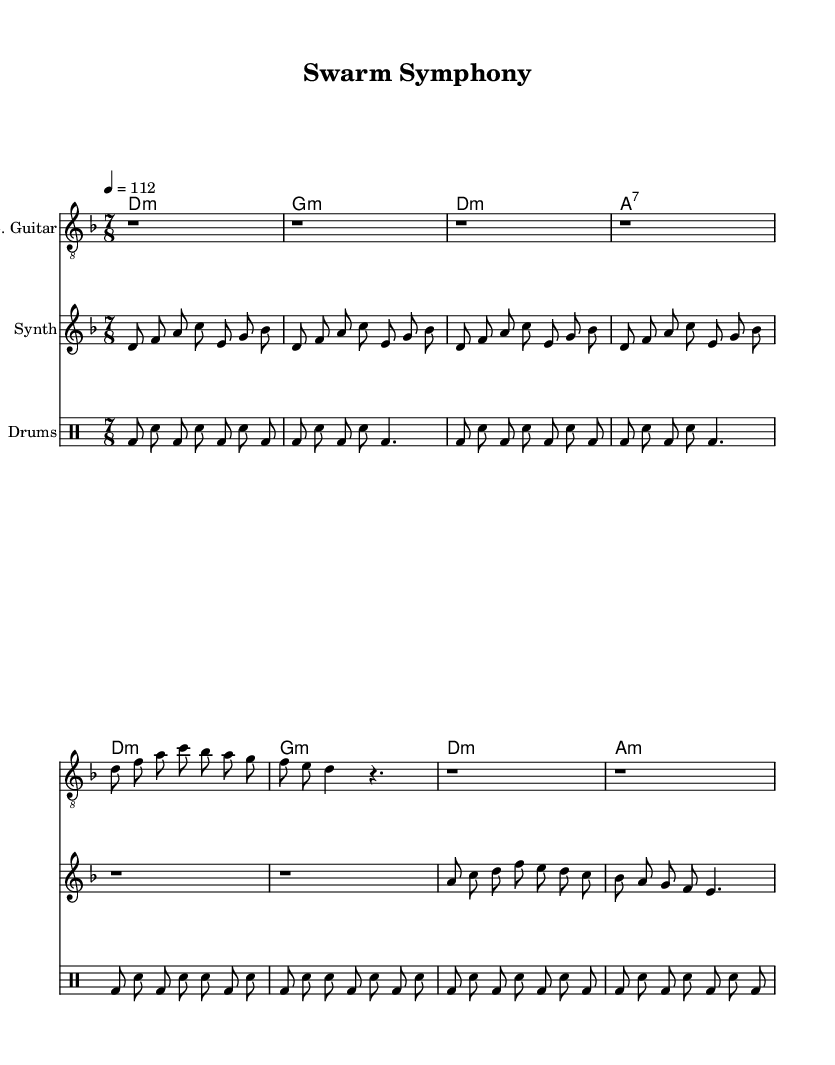What is the key signature of this music? The key signature is indicated at the beginning of the score, which shows one flat, corresponding to D minor.
Answer: D minor What is the time signature of this music? The time signature appears right after the key signature and is displayed as 7/8, indicating a compound time with seven eighth notes per measure.
Answer: 7/8 What is the tempo marking in this score? The tempo marking is found in the global variable section, specifically by the text "4 = 112," which suggests the quarter note should be at a speed of 112 beats per minute.
Answer: 112 How many measures are in the Intro section? By counting the measures listed under the electric guitar, synthesizer, and drum machine for the Intro, there are a total of 6 measures.
Answer: 6 What is the chord played in the Intro? The chords section shows d minor, g minor, d minor, and a7 for the Intro, indicating the specific chords played in that section.
Answer: d minor, g minor, d minor, a7 How does the verse compare to the chorus in terms of complexity? The verse primarily consists of a simpler pattern involving fewer notes, while the chorus features a more straightforward melodic line with a defined structure, indicating the chorus has less complexity.
Answer: Chorus is simpler What role does the synthesizer play in this piece? The synthesizer creates a melodic line that complements the electric guitar and drum machine, incorporating machine-generated sounds that enhance the overall texture of the experimental rock style.
Answer: Complements the electric guitar and drum machine 